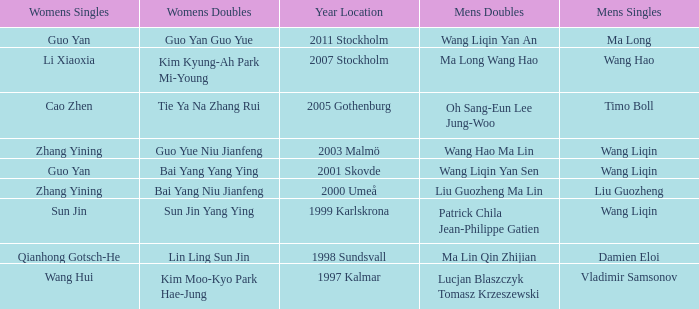What is the place and when was the year when the women's doubles womens were Bai yang Niu Jianfeng? 2000 Umeå. 